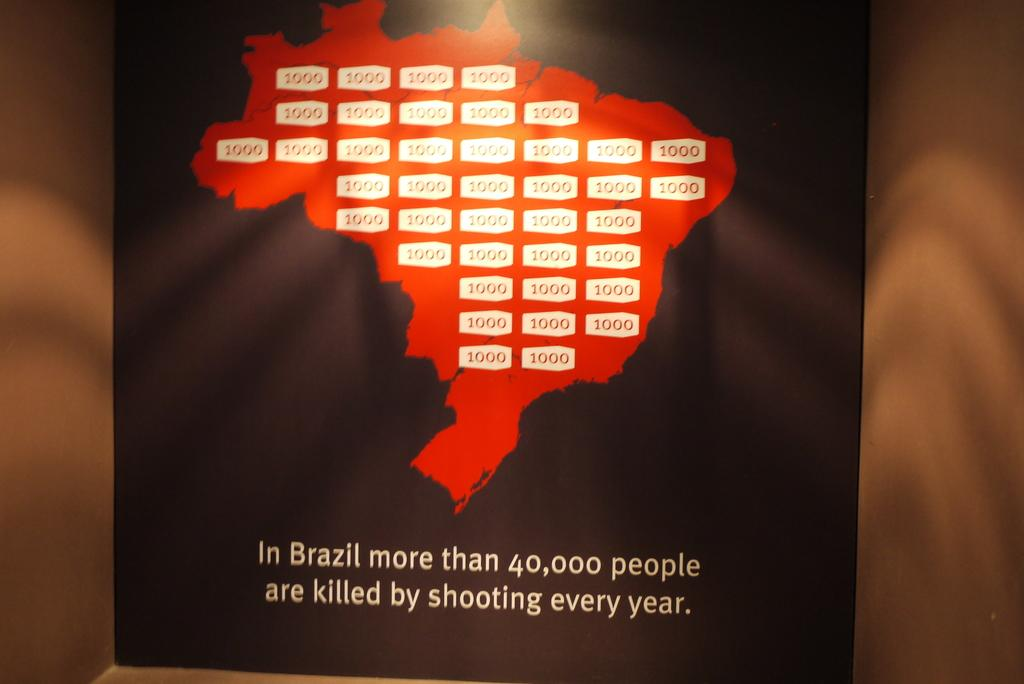<image>
Present a compact description of the photo's key features. A map of Brazil states that "more than 40,000 people are killed by shooting every year" in that country. 